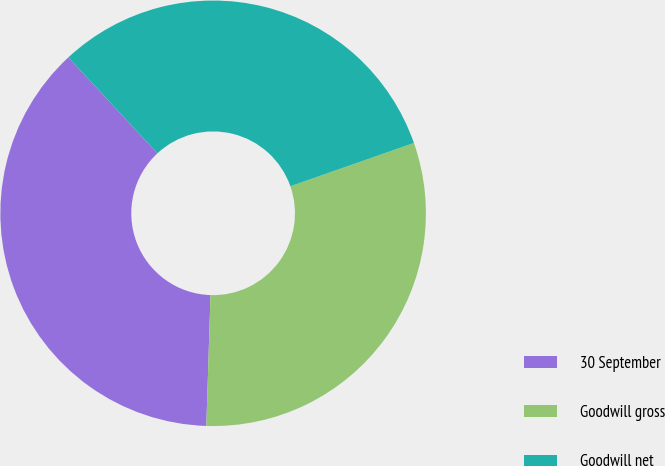Convert chart to OTSL. <chart><loc_0><loc_0><loc_500><loc_500><pie_chart><fcel>30 September<fcel>Goodwill gross<fcel>Goodwill net<nl><fcel>37.58%<fcel>30.87%<fcel>31.55%<nl></chart> 